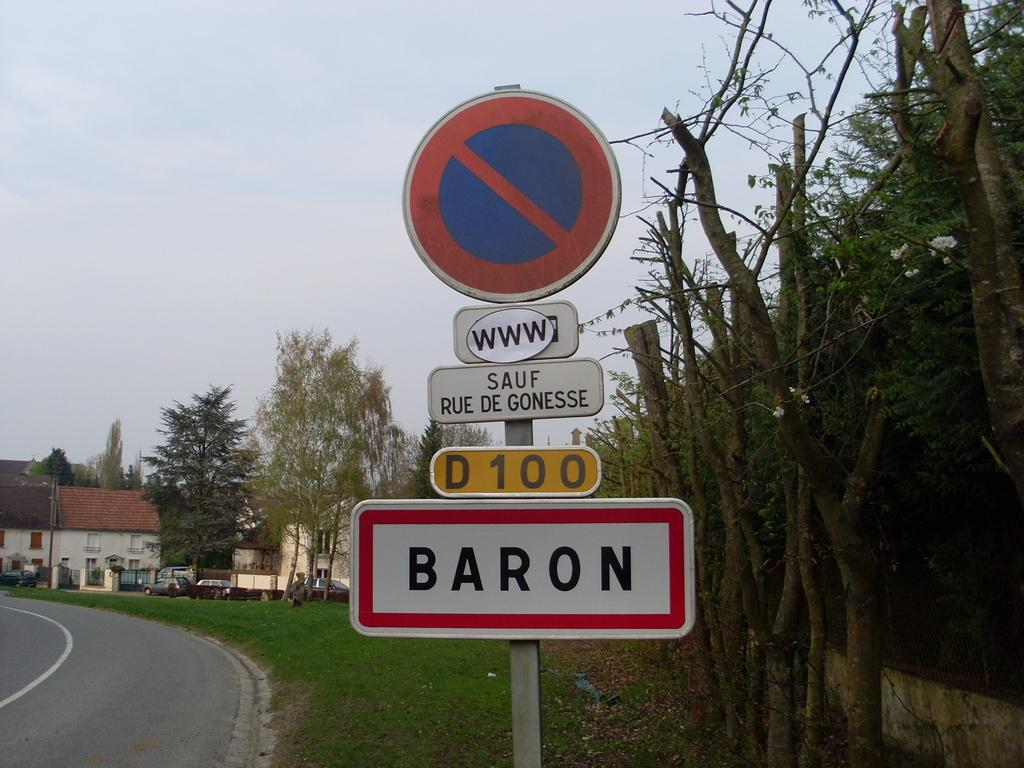<image>
Present a compact description of the photo's key features. A street sign has several things written on it, including that it is Baron Street. 